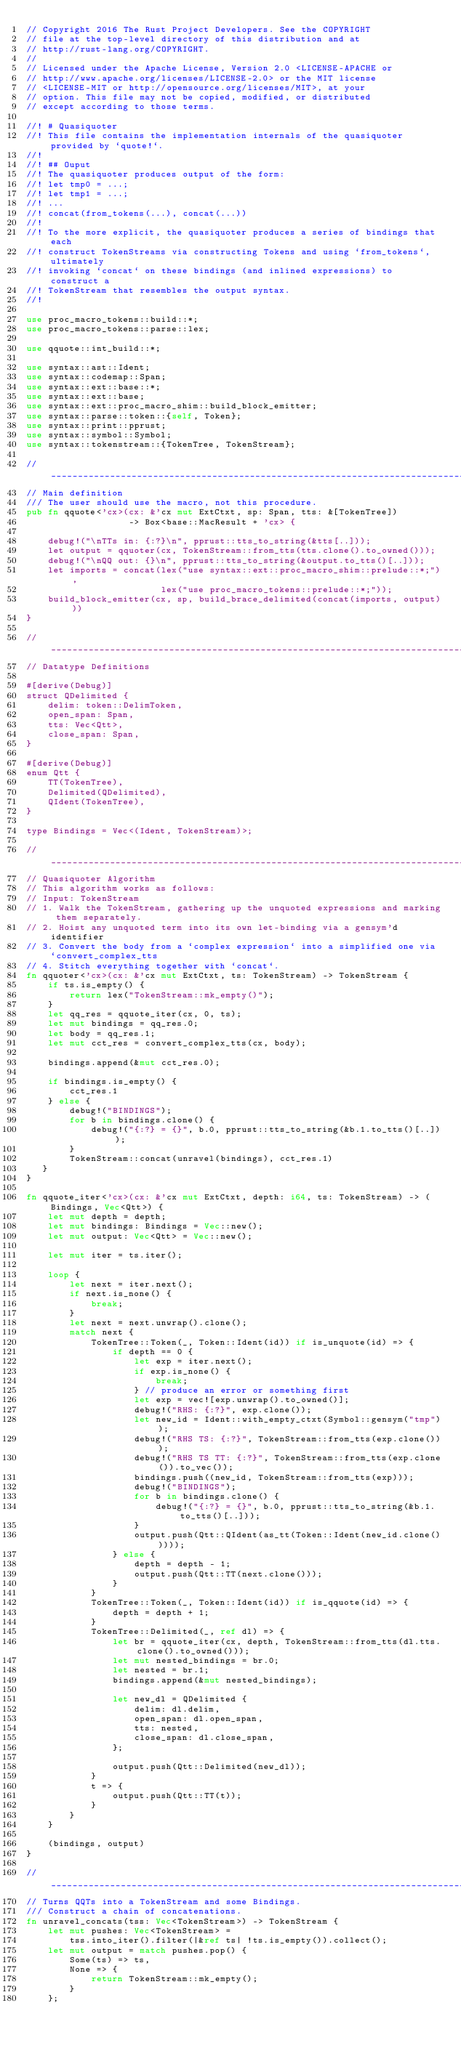Convert code to text. <code><loc_0><loc_0><loc_500><loc_500><_Rust_>// Copyright 2016 The Rust Project Developers. See the COPYRIGHT
// file at the top-level directory of this distribution and at
// http://rust-lang.org/COPYRIGHT.
//
// Licensed under the Apache License, Version 2.0 <LICENSE-APACHE or
// http://www.apache.org/licenses/LICENSE-2.0> or the MIT license
// <LICENSE-MIT or http://opensource.org/licenses/MIT>, at your
// option. This file may not be copied, modified, or distributed
// except according to those terms.

//! # Quasiquoter
//! This file contains the implementation internals of the quasiquoter provided by `quote!`.
//!
//! ## Ouput
//! The quasiquoter produces output of the form:
//! let tmp0 = ...;
//! let tmp1 = ...;
//! ...
//! concat(from_tokens(...), concat(...))
//!
//! To the more explicit, the quasiquoter produces a series of bindings that each
//! construct TokenStreams via constructing Tokens and using `from_tokens`, ultimately
//! invoking `concat` on these bindings (and inlined expressions) to construct a
//! TokenStream that resembles the output syntax.
//!

use proc_macro_tokens::build::*;
use proc_macro_tokens::parse::lex;

use qquote::int_build::*;

use syntax::ast::Ident;
use syntax::codemap::Span;
use syntax::ext::base::*;
use syntax::ext::base;
use syntax::ext::proc_macro_shim::build_block_emitter;
use syntax::parse::token::{self, Token};
use syntax::print::pprust;
use syntax::symbol::Symbol;
use syntax::tokenstream::{TokenTree, TokenStream};

// ____________________________________________________________________________________________
// Main definition
/// The user should use the macro, not this procedure.
pub fn qquote<'cx>(cx: &'cx mut ExtCtxt, sp: Span, tts: &[TokenTree])
                   -> Box<base::MacResult + 'cx> {

    debug!("\nTTs in: {:?}\n", pprust::tts_to_string(&tts[..]));
    let output = qquoter(cx, TokenStream::from_tts(tts.clone().to_owned()));
    debug!("\nQQ out: {}\n", pprust::tts_to_string(&output.to_tts()[..]));
    let imports = concat(lex("use syntax::ext::proc_macro_shim::prelude::*;"),
                         lex("use proc_macro_tokens::prelude::*;"));
    build_block_emitter(cx, sp, build_brace_delimited(concat(imports, output)))
}

// ____________________________________________________________________________________________
// Datatype Definitions

#[derive(Debug)]
struct QDelimited {
    delim: token::DelimToken,
    open_span: Span,
    tts: Vec<Qtt>,
    close_span: Span,
}

#[derive(Debug)]
enum Qtt {
    TT(TokenTree),
    Delimited(QDelimited),
    QIdent(TokenTree),
}

type Bindings = Vec<(Ident, TokenStream)>;

// ____________________________________________________________________________________________
// Quasiquoter Algorithm
// This algorithm works as follows:
// Input: TokenStream
// 1. Walk the TokenStream, gathering up the unquoted expressions and marking them separately.
// 2. Hoist any unquoted term into its own let-binding via a gensym'd identifier
// 3. Convert the body from a `complex expression` into a simplified one via `convert_complex_tts
// 4. Stitch everything together with `concat`.
fn qquoter<'cx>(cx: &'cx mut ExtCtxt, ts: TokenStream) -> TokenStream {
    if ts.is_empty() {
        return lex("TokenStream::mk_empty()");
    }
    let qq_res = qquote_iter(cx, 0, ts);
    let mut bindings = qq_res.0;
    let body = qq_res.1;
    let mut cct_res = convert_complex_tts(cx, body);

    bindings.append(&mut cct_res.0);

    if bindings.is_empty() {
        cct_res.1
    } else {
        debug!("BINDINGS");
        for b in bindings.clone() {
            debug!("{:?} = {}", b.0, pprust::tts_to_string(&b.1.to_tts()[..]));
        }
        TokenStream::concat(unravel(bindings), cct_res.1)
   }
}

fn qquote_iter<'cx>(cx: &'cx mut ExtCtxt, depth: i64, ts: TokenStream) -> (Bindings, Vec<Qtt>) {
    let mut depth = depth;
    let mut bindings: Bindings = Vec::new();
    let mut output: Vec<Qtt> = Vec::new();

    let mut iter = ts.iter();

    loop {
        let next = iter.next();
        if next.is_none() {
            break;
        }
        let next = next.unwrap().clone();
        match next {
            TokenTree::Token(_, Token::Ident(id)) if is_unquote(id) => {
                if depth == 0 {
                    let exp = iter.next();
                    if exp.is_none() {
                        break;
                    } // produce an error or something first
                    let exp = vec![exp.unwrap().to_owned()];
                    debug!("RHS: {:?}", exp.clone());
                    let new_id = Ident::with_empty_ctxt(Symbol::gensym("tmp"));
                    debug!("RHS TS: {:?}", TokenStream::from_tts(exp.clone()));
                    debug!("RHS TS TT: {:?}", TokenStream::from_tts(exp.clone()).to_vec());
                    bindings.push((new_id, TokenStream::from_tts(exp)));
                    debug!("BINDINGS");
                    for b in bindings.clone() {
                        debug!("{:?} = {}", b.0, pprust::tts_to_string(&b.1.to_tts()[..]));
                    }
                    output.push(Qtt::QIdent(as_tt(Token::Ident(new_id.clone()))));
                } else {
                    depth = depth - 1;
                    output.push(Qtt::TT(next.clone()));
                }
            }
            TokenTree::Token(_, Token::Ident(id)) if is_qquote(id) => {
                depth = depth + 1;
            }
            TokenTree::Delimited(_, ref dl) => {
                let br = qquote_iter(cx, depth, TokenStream::from_tts(dl.tts.clone().to_owned()));
                let mut nested_bindings = br.0;
                let nested = br.1;
                bindings.append(&mut nested_bindings);

                let new_dl = QDelimited {
                    delim: dl.delim,
                    open_span: dl.open_span,
                    tts: nested,
                    close_span: dl.close_span,
                };

                output.push(Qtt::Delimited(new_dl));
            }
            t => {
                output.push(Qtt::TT(t));
            }
        }
    }

    (bindings, output)
}

// ____________________________________________________________________________________________
// Turns QQTs into a TokenStream and some Bindings.
/// Construct a chain of concatenations.
fn unravel_concats(tss: Vec<TokenStream>) -> TokenStream {
    let mut pushes: Vec<TokenStream> =
        tss.into_iter().filter(|&ref ts| !ts.is_empty()).collect();
    let mut output = match pushes.pop() {
        Some(ts) => ts,
        None => {
            return TokenStream::mk_empty();
        }
    };
</code> 